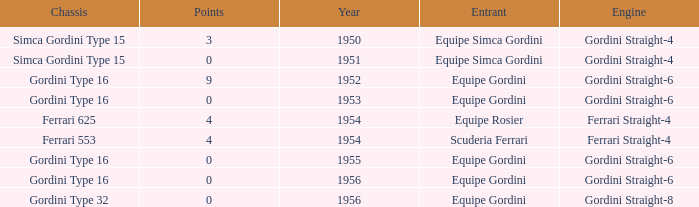Before 1956, what Chassis has Gordini Straight-4 engine with 3 points? Simca Gordini Type 15. 